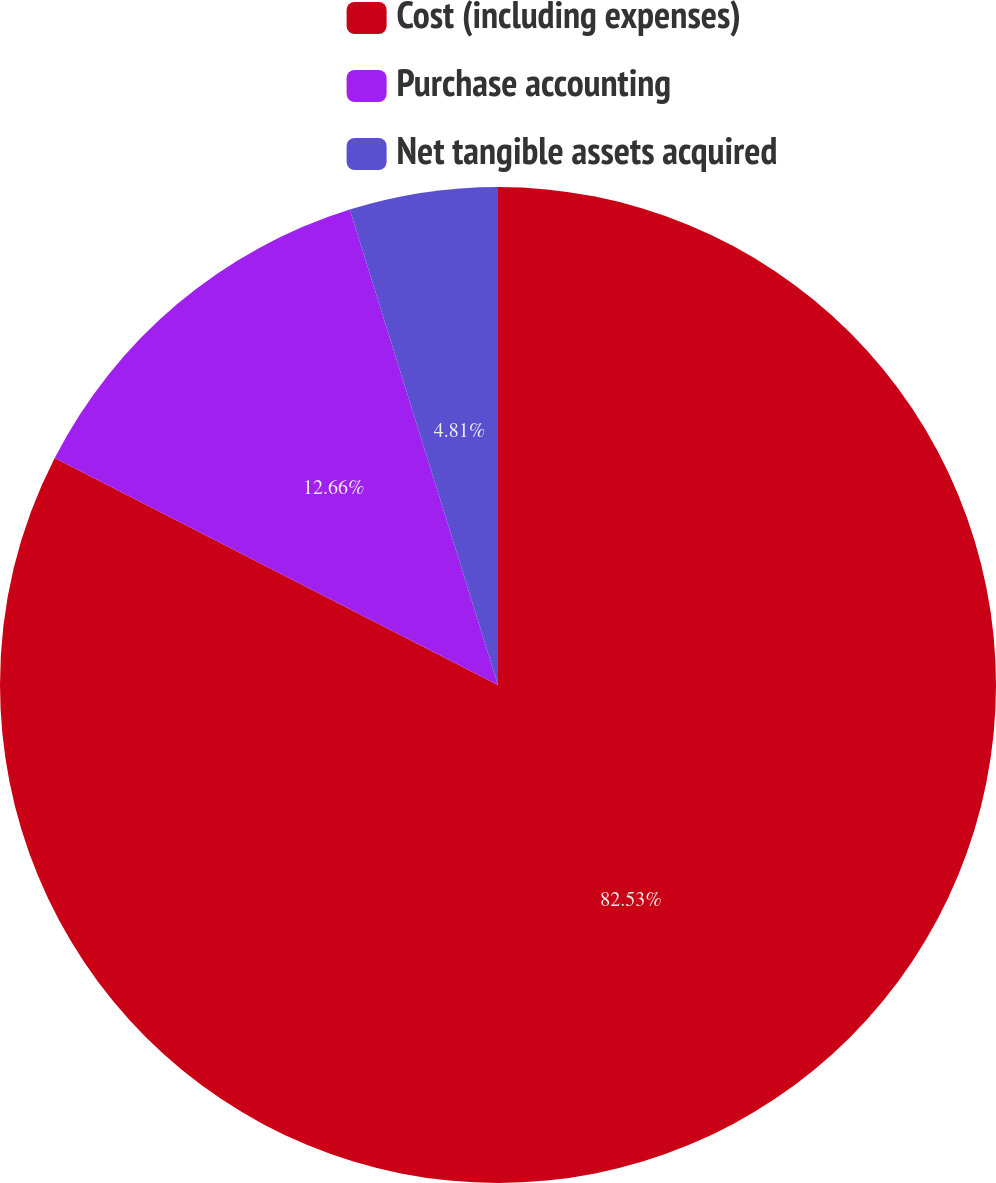Convert chart to OTSL. <chart><loc_0><loc_0><loc_500><loc_500><pie_chart><fcel>Cost (including expenses)<fcel>Purchase accounting<fcel>Net tangible assets acquired<nl><fcel>82.53%<fcel>12.66%<fcel>4.81%<nl></chart> 